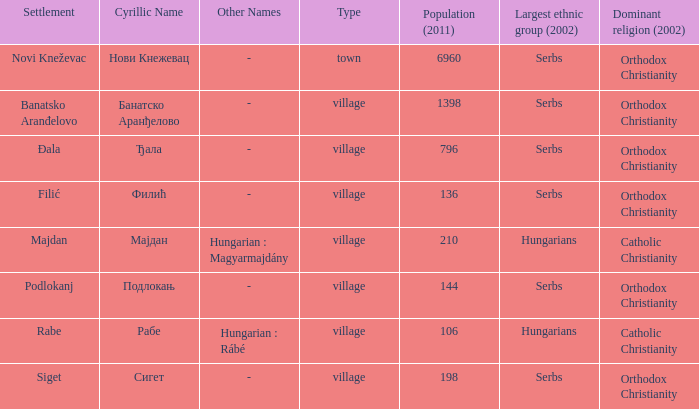Which community has the cyrillic name сигет? Siget. 